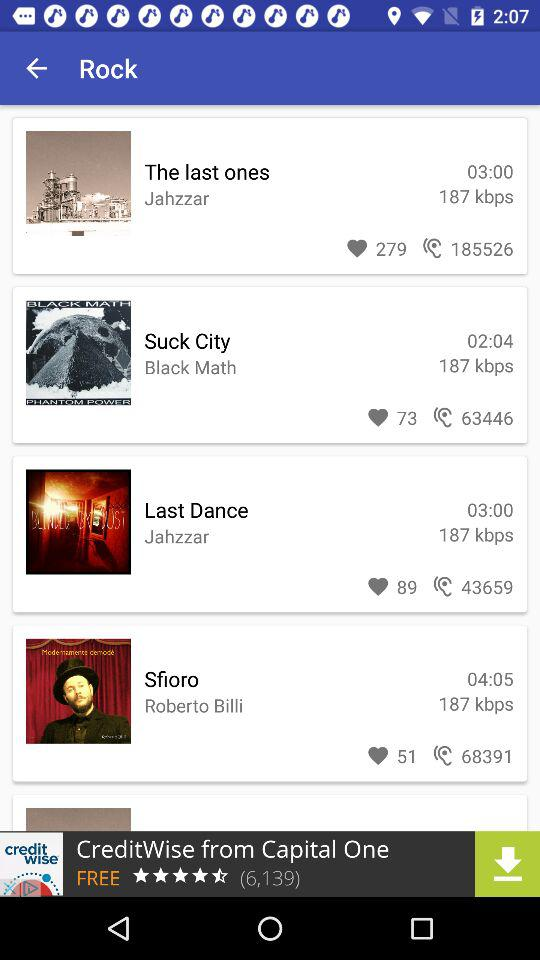How many have liked "The last ones"? There are 279 people who have liked "The last ones". 